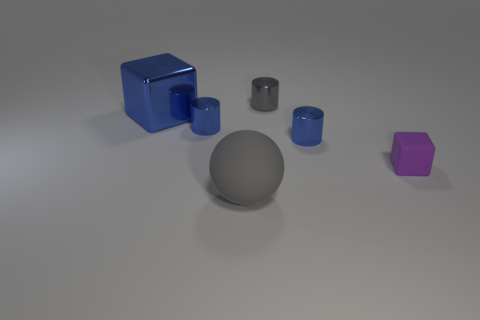What is the size of the gray object that is behind the purple matte block?
Make the answer very short. Small. What size is the gray thing behind the cube right of the cube to the left of the tiny purple matte object?
Ensure brevity in your answer.  Small. What is the color of the shiny cylinder to the right of the gray object on the right side of the big gray object?
Your response must be concise. Blue. There is another purple object that is the same shape as the big shiny object; what is it made of?
Offer a terse response. Rubber. There is a large sphere; are there any small blue metal cylinders on the left side of it?
Your response must be concise. Yes. How many blue blocks are there?
Provide a succinct answer. 1. How many tiny matte blocks are behind the gray thing that is behind the blue cube?
Your answer should be very brief. 0. Does the rubber sphere have the same color as the tiny shiny object behind the blue shiny block?
Ensure brevity in your answer.  Yes. How many tiny blue shiny things are the same shape as the gray matte object?
Your answer should be very brief. 0. What material is the cube on the right side of the sphere?
Ensure brevity in your answer.  Rubber. 